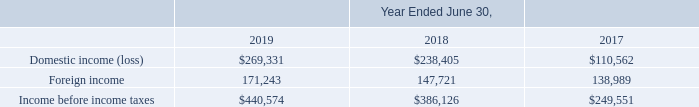NOTE 14—INCOME TAXES
Our effective tax rate represents the net effect of the mix of income earned in various tax jurisdictions that are subject to a wide range of income tax rates.
The following is a geographical breakdown of income before the provision for income taxes:
What does the table represent? Geographical breakdown of income before the provision for income taxes. What does the effective tax rate represent? Net effect of the mix of income earned in various tax jurisdictions that are subject to a wide range of income tax rates. What are the fiscal years included in the table? 2019, 2018, 2017. What is the average annual Income before income taxes? (440,574+386,126+249,551)/3
Answer: 358750.33. For Fiscal year 2019, what is the Foreign income expressed as a percentage of Income before income taxes?
Answer scale should be: percent. 171,243/440,574
Answer: 38.87. In what years did Income before income taxes exceed $300,000? 2019, 2018. 